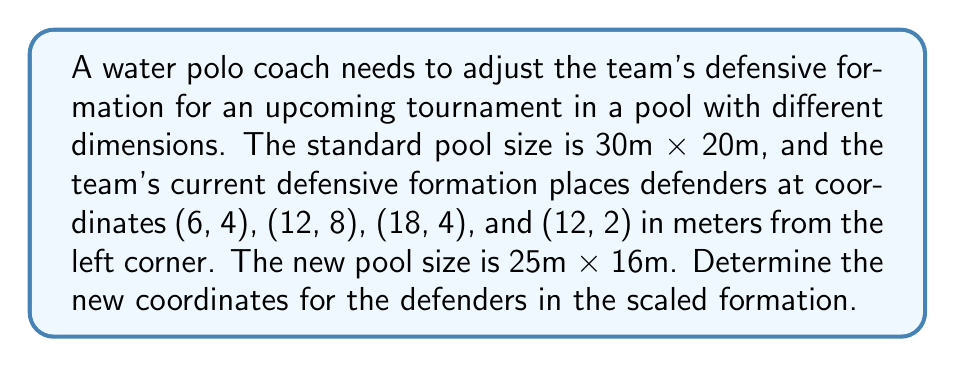What is the answer to this math problem? To solve this problem, we need to use the concept of scaling transformations. The scaling factors for both dimensions can be calculated as follows:

1. Calculate scaling factors:
   $x_{scale} = \frac{\text{new width}}{\text{original width}} = \frac{25}{30} = \frac{5}{6}$
   $y_{scale} = \frac{\text{new height}}{\text{original height}} = \frac{16}{20} = \frac{4}{5}$

2. Apply the scaling transformation to each coordinate:
   For a point $(x, y)$, the new coordinates will be $(x \cdot x_{scale}, y \cdot y_{scale})$

3. Calculate new coordinates for each defender:
   a) (6, 4):
      $x_{new} = 6 \cdot \frac{5}{6} = 5$
      $y_{new} = 4 \cdot \frac{4}{5} = 3.2$
      New position: (5, 3.2)

   b) (12, 8):
      $x_{new} = 12 \cdot \frac{5}{6} = 10$
      $y_{new} = 8 \cdot \frac{4}{5} = 6.4$
      New position: (10, 6.4)

   c) (18, 4):
      $x_{new} = 18 \cdot \frac{5}{6} = 15$
      $y_{new} = 4 \cdot \frac{4}{5} = 3.2$
      New position: (15, 3.2)

   d) (12, 2):
      $x_{new} = 12 \cdot \frac{5}{6} = 10$
      $y_{new} = 2 \cdot \frac{4}{5} = 1.6$
      New position: (10, 1.6)

The new coordinates maintain the relative positions of the defenders in the scaled pool.
Answer: The new coordinates for the defenders in the scaled formation are:
(5, 3.2), (10, 6.4), (15, 3.2), and (10, 1.6) 